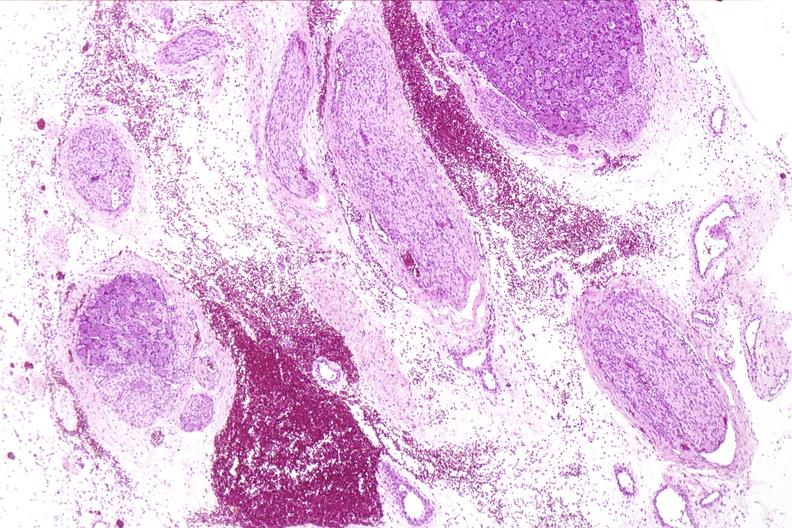does nodular tumor show neural tube defect, meningomyelocele?
Answer the question using a single word or phrase. No 